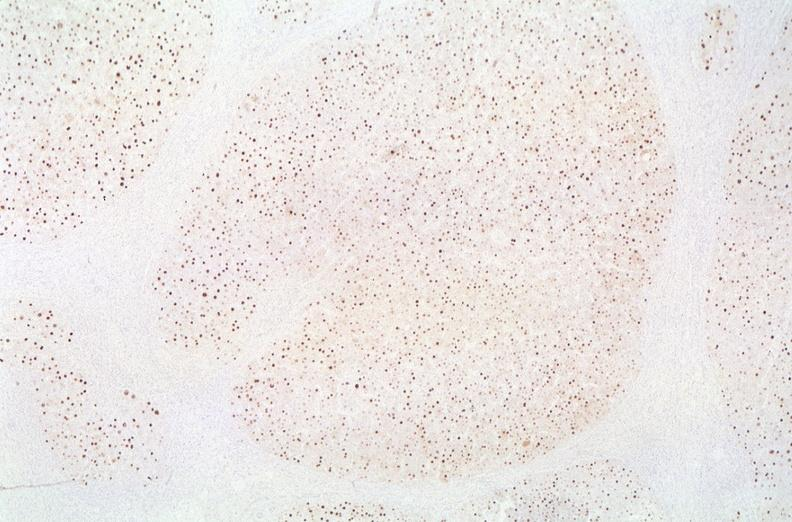what is present?
Answer the question using a single word or phrase. Liver 